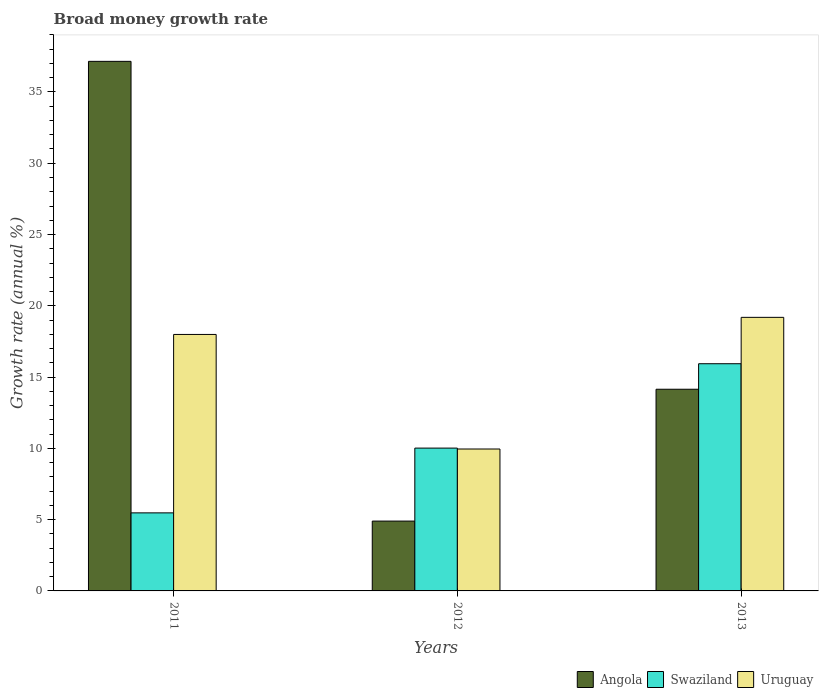Are the number of bars per tick equal to the number of legend labels?
Provide a short and direct response. Yes. What is the label of the 1st group of bars from the left?
Give a very brief answer. 2011. What is the growth rate in Angola in 2012?
Make the answer very short. 4.9. Across all years, what is the maximum growth rate in Angola?
Your answer should be very brief. 37.15. Across all years, what is the minimum growth rate in Swaziland?
Provide a succinct answer. 5.48. What is the total growth rate in Angola in the graph?
Your answer should be compact. 56.19. What is the difference between the growth rate in Angola in 2011 and that in 2013?
Your answer should be very brief. 23. What is the difference between the growth rate in Uruguay in 2012 and the growth rate in Swaziland in 2013?
Ensure brevity in your answer.  -5.98. What is the average growth rate in Swaziland per year?
Offer a terse response. 10.48. In the year 2013, what is the difference between the growth rate in Uruguay and growth rate in Angola?
Make the answer very short. 5.04. In how many years, is the growth rate in Swaziland greater than 21 %?
Ensure brevity in your answer.  0. What is the ratio of the growth rate in Swaziland in 2012 to that in 2013?
Offer a very short reply. 0.63. Is the difference between the growth rate in Uruguay in 2011 and 2013 greater than the difference between the growth rate in Angola in 2011 and 2013?
Your response must be concise. No. What is the difference between the highest and the second highest growth rate in Uruguay?
Ensure brevity in your answer.  1.2. What is the difference between the highest and the lowest growth rate in Uruguay?
Ensure brevity in your answer.  9.24. In how many years, is the growth rate in Angola greater than the average growth rate in Angola taken over all years?
Keep it short and to the point. 1. Is the sum of the growth rate in Angola in 2011 and 2013 greater than the maximum growth rate in Uruguay across all years?
Your answer should be compact. Yes. What does the 3rd bar from the left in 2012 represents?
Provide a short and direct response. Uruguay. What does the 3rd bar from the right in 2011 represents?
Keep it short and to the point. Angola. Is it the case that in every year, the sum of the growth rate in Swaziland and growth rate in Uruguay is greater than the growth rate in Angola?
Make the answer very short. No. What is the difference between two consecutive major ticks on the Y-axis?
Offer a very short reply. 5. Are the values on the major ticks of Y-axis written in scientific E-notation?
Ensure brevity in your answer.  No. Where does the legend appear in the graph?
Your response must be concise. Bottom right. How many legend labels are there?
Your response must be concise. 3. How are the legend labels stacked?
Provide a succinct answer. Horizontal. What is the title of the graph?
Give a very brief answer. Broad money growth rate. What is the label or title of the Y-axis?
Provide a short and direct response. Growth rate (annual %). What is the Growth rate (annual %) in Angola in 2011?
Offer a terse response. 37.15. What is the Growth rate (annual %) of Swaziland in 2011?
Your answer should be compact. 5.48. What is the Growth rate (annual %) of Uruguay in 2011?
Provide a short and direct response. 17.99. What is the Growth rate (annual %) in Angola in 2012?
Offer a terse response. 4.9. What is the Growth rate (annual %) in Swaziland in 2012?
Provide a short and direct response. 10.02. What is the Growth rate (annual %) in Uruguay in 2012?
Offer a terse response. 9.95. What is the Growth rate (annual %) of Angola in 2013?
Make the answer very short. 14.15. What is the Growth rate (annual %) in Swaziland in 2013?
Offer a very short reply. 15.94. What is the Growth rate (annual %) in Uruguay in 2013?
Your answer should be very brief. 19.19. Across all years, what is the maximum Growth rate (annual %) of Angola?
Make the answer very short. 37.15. Across all years, what is the maximum Growth rate (annual %) of Swaziland?
Offer a very short reply. 15.94. Across all years, what is the maximum Growth rate (annual %) of Uruguay?
Your response must be concise. 19.19. Across all years, what is the minimum Growth rate (annual %) in Angola?
Provide a succinct answer. 4.9. Across all years, what is the minimum Growth rate (annual %) in Swaziland?
Give a very brief answer. 5.48. Across all years, what is the minimum Growth rate (annual %) in Uruguay?
Ensure brevity in your answer.  9.95. What is the total Growth rate (annual %) in Angola in the graph?
Make the answer very short. 56.19. What is the total Growth rate (annual %) in Swaziland in the graph?
Your answer should be compact. 31.43. What is the total Growth rate (annual %) of Uruguay in the graph?
Ensure brevity in your answer.  47.13. What is the difference between the Growth rate (annual %) of Angola in 2011 and that in 2012?
Ensure brevity in your answer.  32.25. What is the difference between the Growth rate (annual %) of Swaziland in 2011 and that in 2012?
Offer a terse response. -4.54. What is the difference between the Growth rate (annual %) of Uruguay in 2011 and that in 2012?
Give a very brief answer. 8.04. What is the difference between the Growth rate (annual %) in Angola in 2011 and that in 2013?
Provide a short and direct response. 23. What is the difference between the Growth rate (annual %) of Swaziland in 2011 and that in 2013?
Ensure brevity in your answer.  -10.46. What is the difference between the Growth rate (annual %) in Uruguay in 2011 and that in 2013?
Provide a succinct answer. -1.2. What is the difference between the Growth rate (annual %) in Angola in 2012 and that in 2013?
Offer a terse response. -9.25. What is the difference between the Growth rate (annual %) in Swaziland in 2012 and that in 2013?
Ensure brevity in your answer.  -5.92. What is the difference between the Growth rate (annual %) in Uruguay in 2012 and that in 2013?
Your answer should be very brief. -9.24. What is the difference between the Growth rate (annual %) in Angola in 2011 and the Growth rate (annual %) in Swaziland in 2012?
Offer a very short reply. 27.13. What is the difference between the Growth rate (annual %) in Angola in 2011 and the Growth rate (annual %) in Uruguay in 2012?
Offer a very short reply. 27.19. What is the difference between the Growth rate (annual %) in Swaziland in 2011 and the Growth rate (annual %) in Uruguay in 2012?
Ensure brevity in your answer.  -4.48. What is the difference between the Growth rate (annual %) of Angola in 2011 and the Growth rate (annual %) of Swaziland in 2013?
Make the answer very short. 21.21. What is the difference between the Growth rate (annual %) in Angola in 2011 and the Growth rate (annual %) in Uruguay in 2013?
Make the answer very short. 17.96. What is the difference between the Growth rate (annual %) of Swaziland in 2011 and the Growth rate (annual %) of Uruguay in 2013?
Offer a terse response. -13.71. What is the difference between the Growth rate (annual %) in Angola in 2012 and the Growth rate (annual %) in Swaziland in 2013?
Offer a terse response. -11.04. What is the difference between the Growth rate (annual %) of Angola in 2012 and the Growth rate (annual %) of Uruguay in 2013?
Offer a terse response. -14.29. What is the difference between the Growth rate (annual %) in Swaziland in 2012 and the Growth rate (annual %) in Uruguay in 2013?
Provide a short and direct response. -9.17. What is the average Growth rate (annual %) in Angola per year?
Offer a terse response. 18.73. What is the average Growth rate (annual %) in Swaziland per year?
Give a very brief answer. 10.48. What is the average Growth rate (annual %) in Uruguay per year?
Give a very brief answer. 15.71. In the year 2011, what is the difference between the Growth rate (annual %) in Angola and Growth rate (annual %) in Swaziland?
Provide a succinct answer. 31.67. In the year 2011, what is the difference between the Growth rate (annual %) in Angola and Growth rate (annual %) in Uruguay?
Offer a terse response. 19.16. In the year 2011, what is the difference between the Growth rate (annual %) in Swaziland and Growth rate (annual %) in Uruguay?
Your answer should be very brief. -12.52. In the year 2012, what is the difference between the Growth rate (annual %) in Angola and Growth rate (annual %) in Swaziland?
Give a very brief answer. -5.12. In the year 2012, what is the difference between the Growth rate (annual %) of Angola and Growth rate (annual %) of Uruguay?
Offer a very short reply. -5.06. In the year 2012, what is the difference between the Growth rate (annual %) in Swaziland and Growth rate (annual %) in Uruguay?
Ensure brevity in your answer.  0.06. In the year 2013, what is the difference between the Growth rate (annual %) in Angola and Growth rate (annual %) in Swaziland?
Your answer should be very brief. -1.79. In the year 2013, what is the difference between the Growth rate (annual %) in Angola and Growth rate (annual %) in Uruguay?
Make the answer very short. -5.04. In the year 2013, what is the difference between the Growth rate (annual %) of Swaziland and Growth rate (annual %) of Uruguay?
Your answer should be compact. -3.25. What is the ratio of the Growth rate (annual %) in Angola in 2011 to that in 2012?
Your answer should be very brief. 7.58. What is the ratio of the Growth rate (annual %) in Swaziland in 2011 to that in 2012?
Your response must be concise. 0.55. What is the ratio of the Growth rate (annual %) of Uruguay in 2011 to that in 2012?
Offer a terse response. 1.81. What is the ratio of the Growth rate (annual %) in Angola in 2011 to that in 2013?
Your answer should be very brief. 2.63. What is the ratio of the Growth rate (annual %) in Swaziland in 2011 to that in 2013?
Offer a terse response. 0.34. What is the ratio of the Growth rate (annual %) in Uruguay in 2011 to that in 2013?
Give a very brief answer. 0.94. What is the ratio of the Growth rate (annual %) of Angola in 2012 to that in 2013?
Your response must be concise. 0.35. What is the ratio of the Growth rate (annual %) of Swaziland in 2012 to that in 2013?
Give a very brief answer. 0.63. What is the ratio of the Growth rate (annual %) of Uruguay in 2012 to that in 2013?
Ensure brevity in your answer.  0.52. What is the difference between the highest and the second highest Growth rate (annual %) in Angola?
Your answer should be very brief. 23. What is the difference between the highest and the second highest Growth rate (annual %) of Swaziland?
Make the answer very short. 5.92. What is the difference between the highest and the second highest Growth rate (annual %) of Uruguay?
Keep it short and to the point. 1.2. What is the difference between the highest and the lowest Growth rate (annual %) of Angola?
Offer a terse response. 32.25. What is the difference between the highest and the lowest Growth rate (annual %) of Swaziland?
Ensure brevity in your answer.  10.46. What is the difference between the highest and the lowest Growth rate (annual %) of Uruguay?
Ensure brevity in your answer.  9.24. 